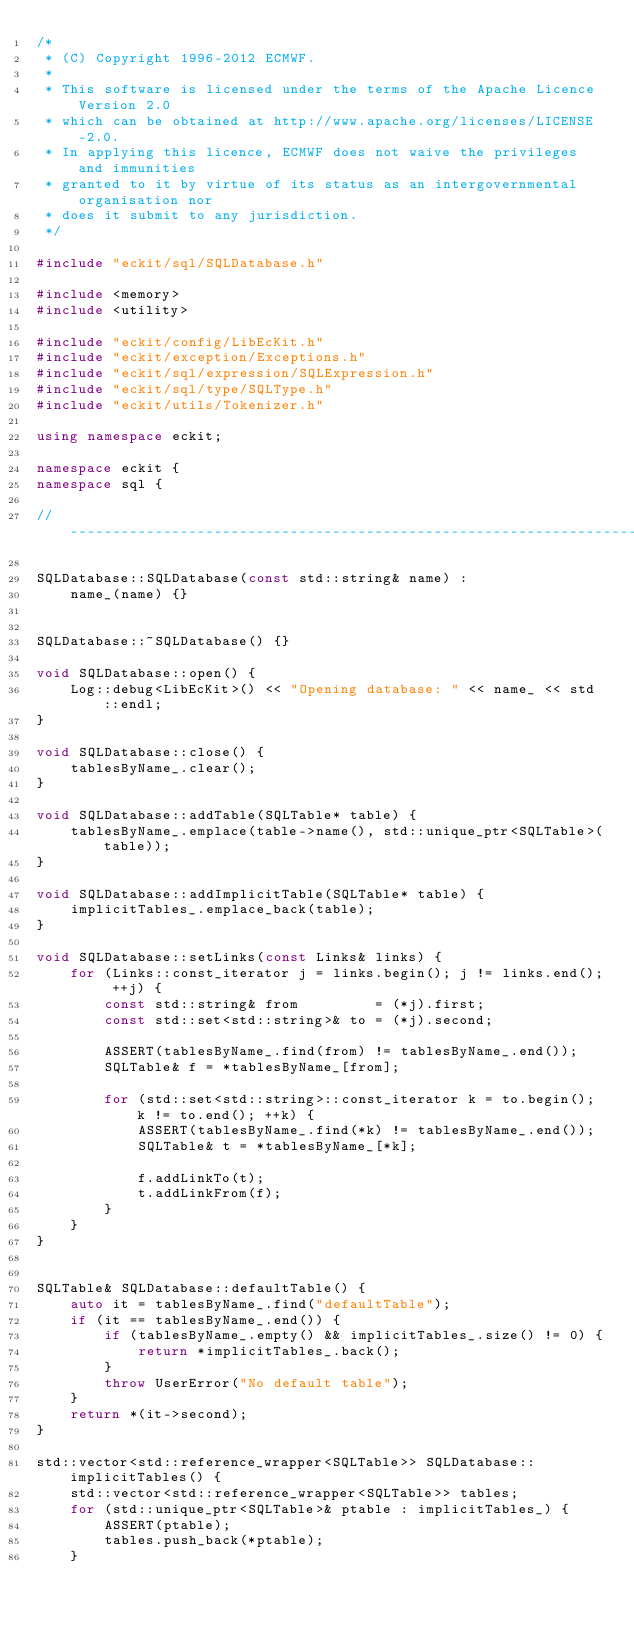Convert code to text. <code><loc_0><loc_0><loc_500><loc_500><_C++_>/*
 * (C) Copyright 1996-2012 ECMWF.
 *
 * This software is licensed under the terms of the Apache Licence Version 2.0
 * which can be obtained at http://www.apache.org/licenses/LICENSE-2.0.
 * In applying this licence, ECMWF does not waive the privileges and immunities
 * granted to it by virtue of its status as an intergovernmental organisation nor
 * does it submit to any jurisdiction.
 */

#include "eckit/sql/SQLDatabase.h"

#include <memory>
#include <utility>

#include "eckit/config/LibEcKit.h"
#include "eckit/exception/Exceptions.h"
#include "eckit/sql/expression/SQLExpression.h"
#include "eckit/sql/type/SQLType.h"
#include "eckit/utils/Tokenizer.h"

using namespace eckit;

namespace eckit {
namespace sql {

//----------------------------------------------------------------------------------------------------------------------

SQLDatabase::SQLDatabase(const std::string& name) :
    name_(name) {}


SQLDatabase::~SQLDatabase() {}

void SQLDatabase::open() {
    Log::debug<LibEcKit>() << "Opening database: " << name_ << std::endl;
}

void SQLDatabase::close() {
    tablesByName_.clear();
}

void SQLDatabase::addTable(SQLTable* table) {
    tablesByName_.emplace(table->name(), std::unique_ptr<SQLTable>(table));
}

void SQLDatabase::addImplicitTable(SQLTable* table) {
    implicitTables_.emplace_back(table);
}

void SQLDatabase::setLinks(const Links& links) {
    for (Links::const_iterator j = links.begin(); j != links.end(); ++j) {
        const std::string& from         = (*j).first;
        const std::set<std::string>& to = (*j).second;

        ASSERT(tablesByName_.find(from) != tablesByName_.end());
        SQLTable& f = *tablesByName_[from];

        for (std::set<std::string>::const_iterator k = to.begin(); k != to.end(); ++k) {
            ASSERT(tablesByName_.find(*k) != tablesByName_.end());
            SQLTable& t = *tablesByName_[*k];

            f.addLinkTo(t);
            t.addLinkFrom(f);
        }
    }
}


SQLTable& SQLDatabase::defaultTable() {
    auto it = tablesByName_.find("defaultTable");
    if (it == tablesByName_.end()) {
        if (tablesByName_.empty() && implicitTables_.size() != 0) {
            return *implicitTables_.back();
        }
        throw UserError("No default table");
    }
    return *(it->second);
}

std::vector<std::reference_wrapper<SQLTable>> SQLDatabase::implicitTables() {
    std::vector<std::reference_wrapper<SQLTable>> tables;
    for (std::unique_ptr<SQLTable>& ptable : implicitTables_) {
        ASSERT(ptable);
        tables.push_back(*ptable);
    }</code> 